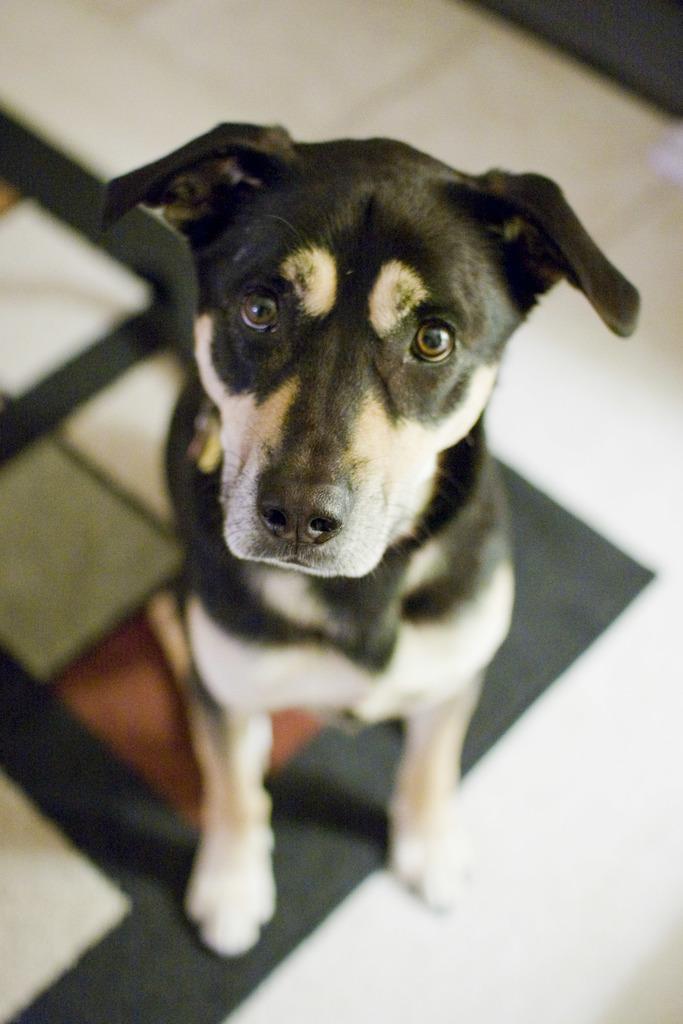In one or two sentences, can you explain what this image depicts? In this image there is a black and white color dog as we can see in middle of this image and there is floor in the background. 